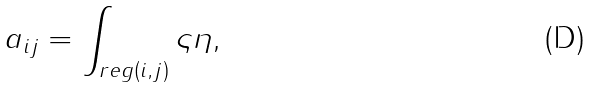Convert formula to latex. <formula><loc_0><loc_0><loc_500><loc_500>a _ { i j } = \int _ { r e g ( i , j ) } \varsigma \eta ,</formula> 